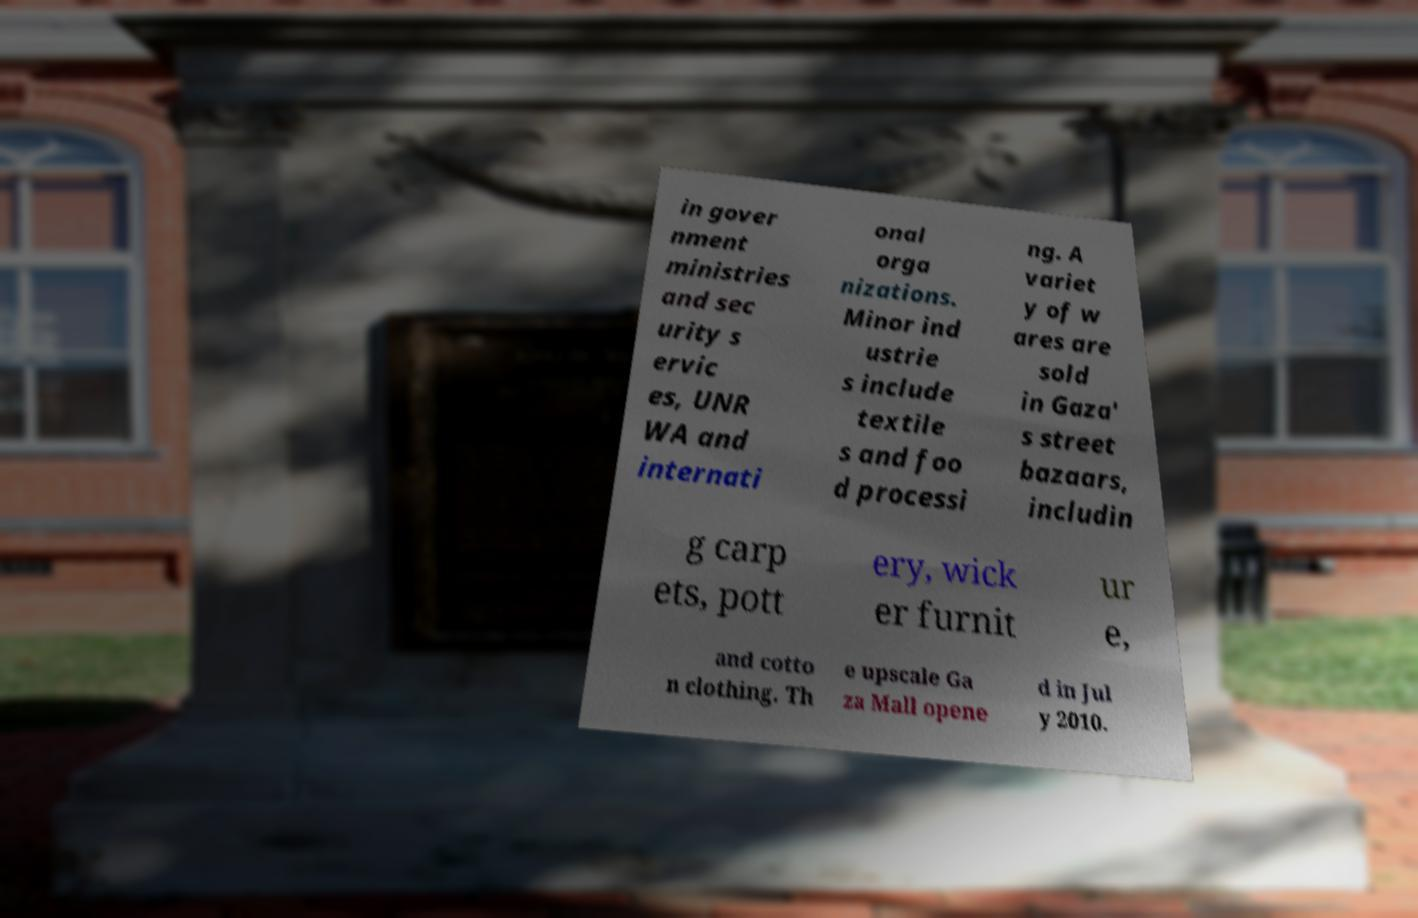Please identify and transcribe the text found in this image. in gover nment ministries and sec urity s ervic es, UNR WA and internati onal orga nizations. Minor ind ustrie s include textile s and foo d processi ng. A variet y of w ares are sold in Gaza' s street bazaars, includin g carp ets, pott ery, wick er furnit ur e, and cotto n clothing. Th e upscale Ga za Mall opene d in Jul y 2010. 